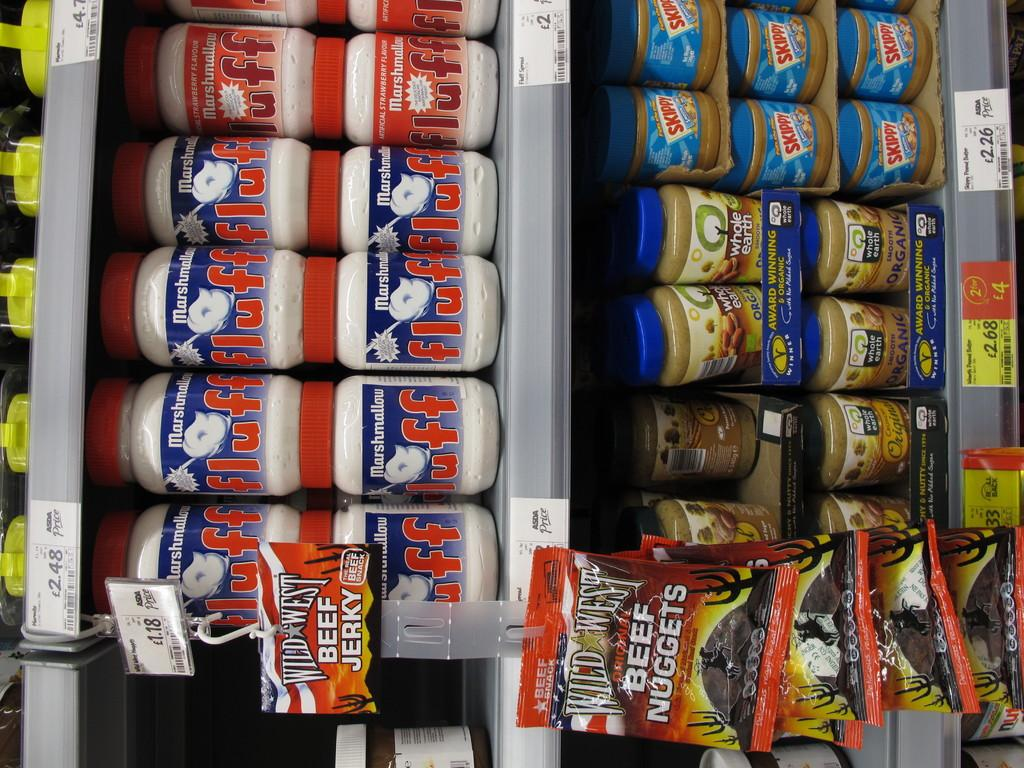<image>
Give a short and clear explanation of the subsequent image. Jars of marshmallow fluff are above jars of peanut butter. 